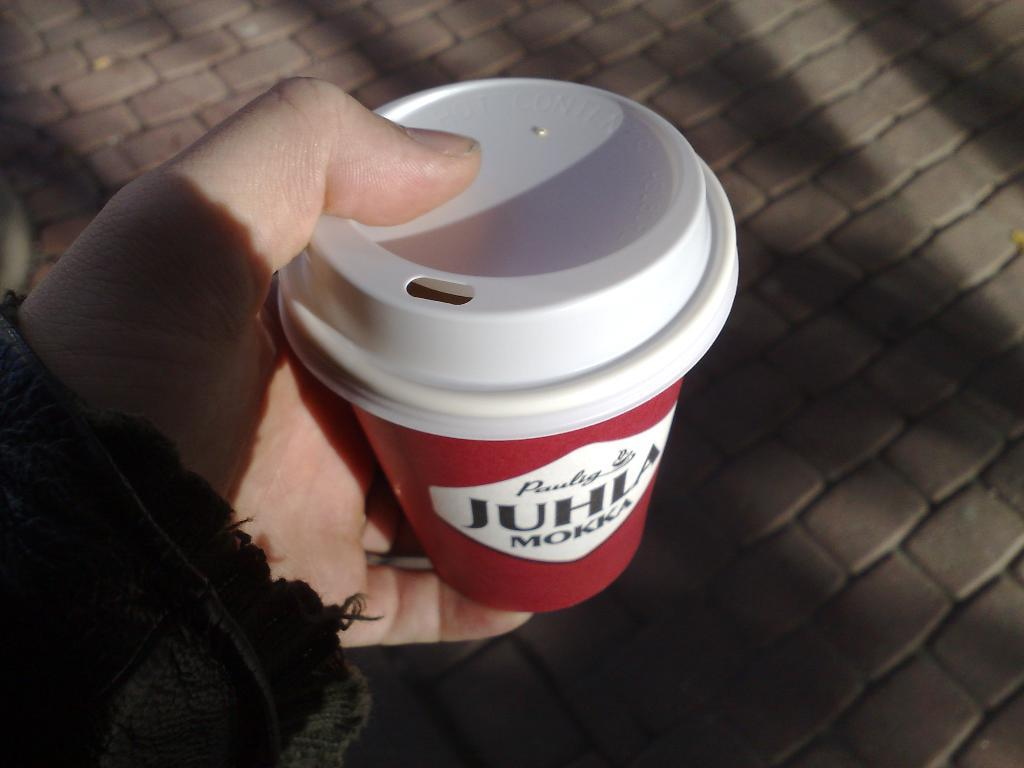What is the person holding in the image? The person is holding a cup in the image. What is written on the cup? The cup is labelled "juhla mokka". What can be seen in the background of the image? There is a cobblestone path in the background of the image. What type of bomb is being used in the competition in the image? There is no bomb or competition present in the image; it features a person holding a cup with a label. 